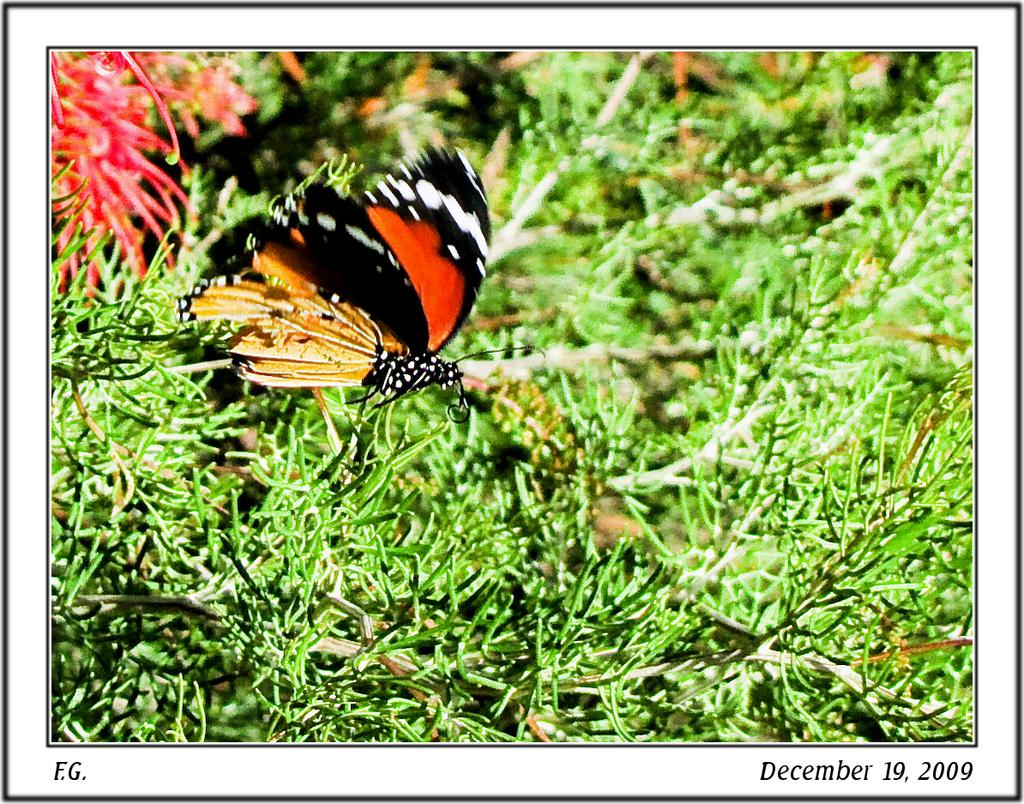What type of insect can be seen in the image? There is a butterfly in the image. What type of plant is visible in the image? There is a flower in the image. What other natural elements can be seen in the image? Leaves are present in the image. Can you tell me how many times the butterfly swims around the flower in the image? Butterflies do not swim; they fly. In the image, the butterfly is not shown flying around the flower. 